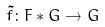Convert formula to latex. <formula><loc_0><loc_0><loc_500><loc_500>\tilde { f } \colon F * G \rightarrow G</formula> 